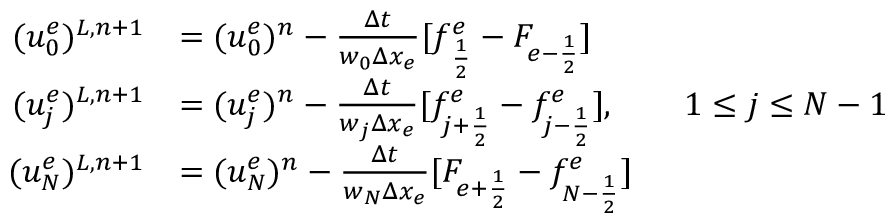Convert formula to latex. <formula><loc_0><loc_0><loc_500><loc_500>\begin{array} { r l } { ( u _ { 0 } ^ { e } ) ^ { L , n + 1 } } & { = ( u _ { 0 } ^ { e } ) ^ { n } - \frac { \Delta t } { w _ { 0 } \Delta x _ { e } } [ f _ { \frac { 1 } { 2 } } ^ { e } - F _ { e - \frac { 1 } { 2 } } ] } \\ { ( u _ { j } ^ { e } ) ^ { L , n + 1 } } & { = ( u _ { j } ^ { e } ) ^ { n } - \frac { \Delta t } { w _ { j } \Delta x _ { e } } [ f _ { j + \frac { 1 } { 2 } } ^ { e } - f _ { j - \frac { 1 } { 2 } } ^ { e } ] , \quad 1 \leq j \leq N - 1 } \\ { ( u _ { N } ^ { e } ) ^ { L , n + 1 } } & { = ( u _ { N } ^ { e } ) ^ { n } - \frac { \Delta t } { w _ { N } \Delta x _ { e } } [ F _ { e + \frac { 1 } { 2 } } - f _ { N - \frac { 1 } { 2 } } ^ { e } ] } \end{array}</formula> 